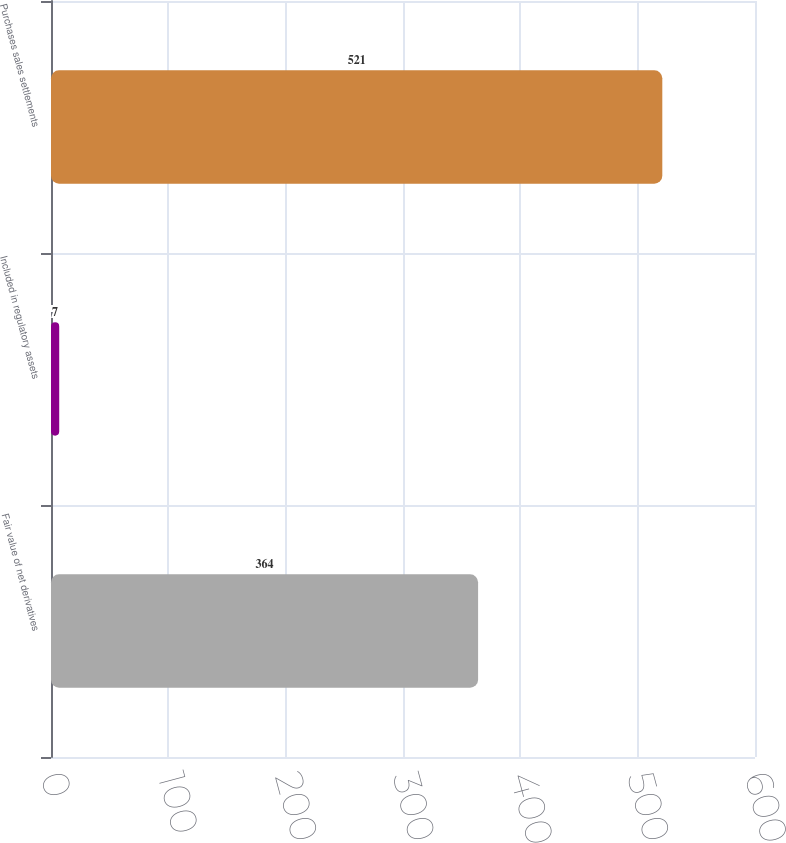Convert chart. <chart><loc_0><loc_0><loc_500><loc_500><bar_chart><fcel>Fair value of net derivatives<fcel>Included in regulatory assets<fcel>Purchases sales settlements<nl><fcel>364<fcel>7<fcel>521<nl></chart> 